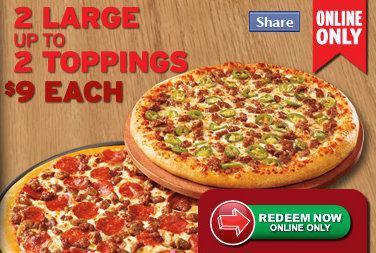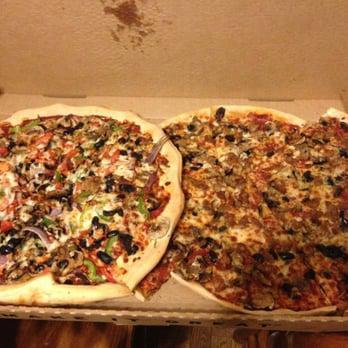The first image is the image on the left, the second image is the image on the right. For the images displayed, is the sentence "There are more pizzas in the image on the left." factually correct? Answer yes or no. No. The first image is the image on the left, the second image is the image on the right. Analyze the images presented: Is the assertion "Exactly one pizza contains pepperoni." valid? Answer yes or no. Yes. 